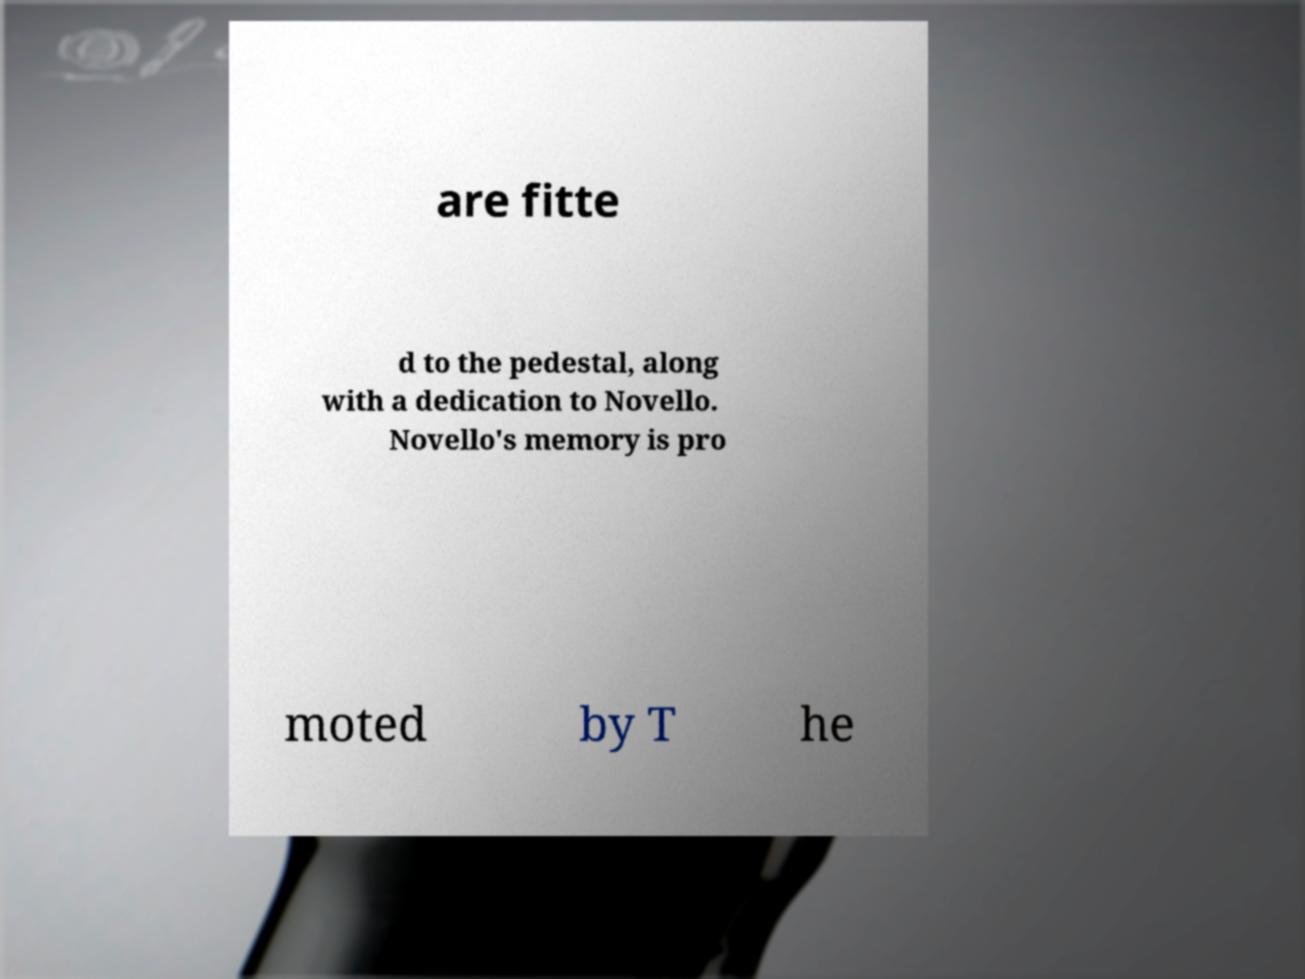Can you read and provide the text displayed in the image?This photo seems to have some interesting text. Can you extract and type it out for me? are fitte d to the pedestal, along with a dedication to Novello. Novello's memory is pro moted by T he 